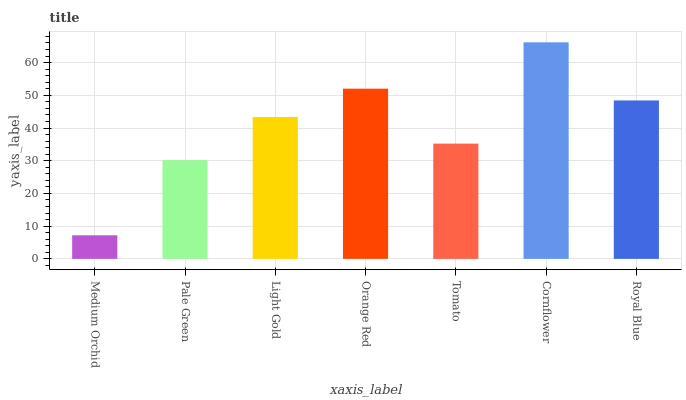Is Pale Green the minimum?
Answer yes or no. No. Is Pale Green the maximum?
Answer yes or no. No. Is Pale Green greater than Medium Orchid?
Answer yes or no. Yes. Is Medium Orchid less than Pale Green?
Answer yes or no. Yes. Is Medium Orchid greater than Pale Green?
Answer yes or no. No. Is Pale Green less than Medium Orchid?
Answer yes or no. No. Is Light Gold the high median?
Answer yes or no. Yes. Is Light Gold the low median?
Answer yes or no. Yes. Is Orange Red the high median?
Answer yes or no. No. Is Cornflower the low median?
Answer yes or no. No. 